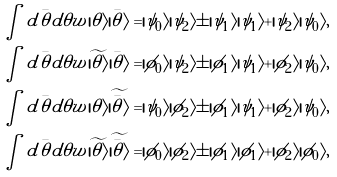<formula> <loc_0><loc_0><loc_500><loc_500>\int d \bar { \theta } d \theta w | \theta \rangle | \bar { \theta } \rangle = | \psi _ { 0 } \rangle | \psi _ { 2 } \rangle \pm | \psi _ { 1 } \rangle | \psi _ { 1 } \rangle + | \psi _ { 2 } \rangle | \psi _ { 0 } \rangle , \\ \int d \bar { \theta } d \theta w \widetilde { | \theta \rangle } | \bar { \theta } \rangle = | \phi _ { 0 } \rangle | \psi _ { 2 } \rangle \pm | \phi _ { 1 } \rangle | \psi _ { 1 } \rangle + | \phi _ { 2 } \rangle | \psi _ { 0 } \rangle , \\ \int d \bar { \theta } d \theta w | \theta \rangle \widetilde { | \bar { \theta } \rangle } = | \psi _ { 0 } \rangle | \phi _ { 2 } \rangle \pm | \phi _ { 1 } \rangle | \psi _ { 1 } \rangle + | \phi _ { 2 } \rangle | \psi _ { 0 } \rangle , \\ \int d \bar { \theta } d \theta w \widetilde { | \theta \rangle } \widetilde { | \bar { \theta } \rangle } = | \phi _ { 0 } \rangle | \phi _ { 2 } \rangle \pm | \phi _ { 1 } \rangle | \phi _ { 1 } \rangle + | \phi _ { 2 } \rangle | \phi _ { 0 } \rangle ,</formula> 